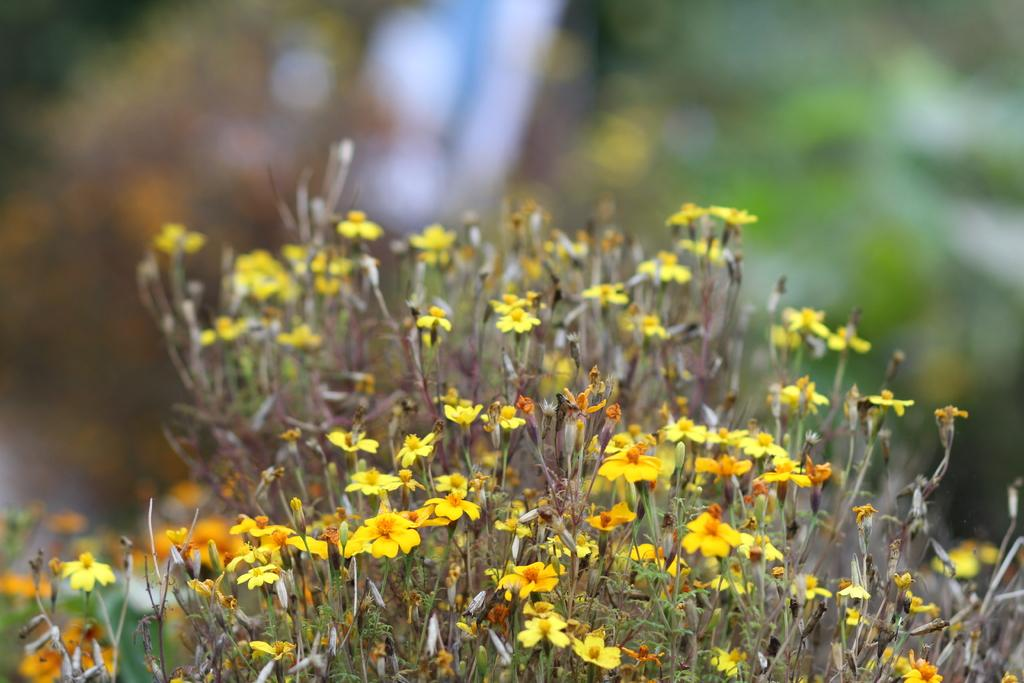What type of plant is in the image? There is a yellow color flower plant in the image. Can you describe the background of the image? The background of the image is blurred. How many tickets are visible in the image? There are no tickets present in the image. What is the position of the person's toes in the image? There are no people or toes visible in the image. 